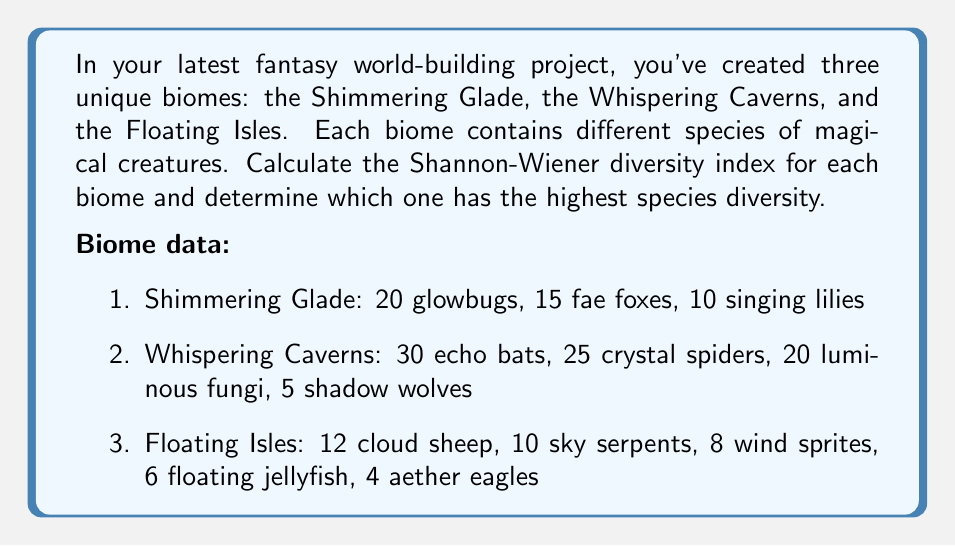Teach me how to tackle this problem. To calculate the Shannon-Wiener diversity index for each biome, we'll use the formula:

$$ H' = -\sum_{i=1}^{R} p_i \ln(p_i) $$

Where:
$H'$ is the Shannon-Wiener diversity index
$R$ is the number of species in the biome
$p_i$ is the proportion of individuals belonging to the $i$-th species

Let's calculate for each biome:

1. Shimmering Glade:
Total individuals: 20 + 15 + 10 = 45

$p_1 = 20/45$, $p_2 = 15/45$, $p_3 = 10/45$

$H' = -[(20/45)\ln(20/45) + (15/45)\ln(15/45) + (10/45)\ln(10/45)]$
$H' \approx 1.0549$

2. Whispering Caverns:
Total individuals: 30 + 25 + 20 + 5 = 80

$p_1 = 30/80$, $p_2 = 25/80$, $p_3 = 20/80$, $p_4 = 5/80$

$H' = -[(30/80)\ln(30/80) + (25/80)\ln(25/80) + (20/80)\ln(20/80) + (5/80)\ln(5/80)]$
$H' \approx 1.3183$

3. Floating Isles:
Total individuals: 12 + 10 + 8 + 6 + 4 = 40

$p_1 = 12/40$, $p_2 = 10/40$, $p_3 = 8/40$, $p_4 = 6/40$, $p_5 = 4/40$

$H' = -[(12/40)\ln(12/40) + (10/40)\ln(10/40) + (8/40)\ln(8/40) + (6/40)\ln(6/40) + (4/40)\ln(4/40)]$
$H' \approx 1.5479$
Answer: The Shannon-Wiener diversity indices for each biome are:
Shimmering Glade: $H' \approx 1.0549$
Whispering Caverns: $H' \approx 1.3183$
Floating Isles: $H' \approx 1.5479$

The Floating Isles has the highest species diversity with a Shannon-Wiener index of approximately 1.5479. 